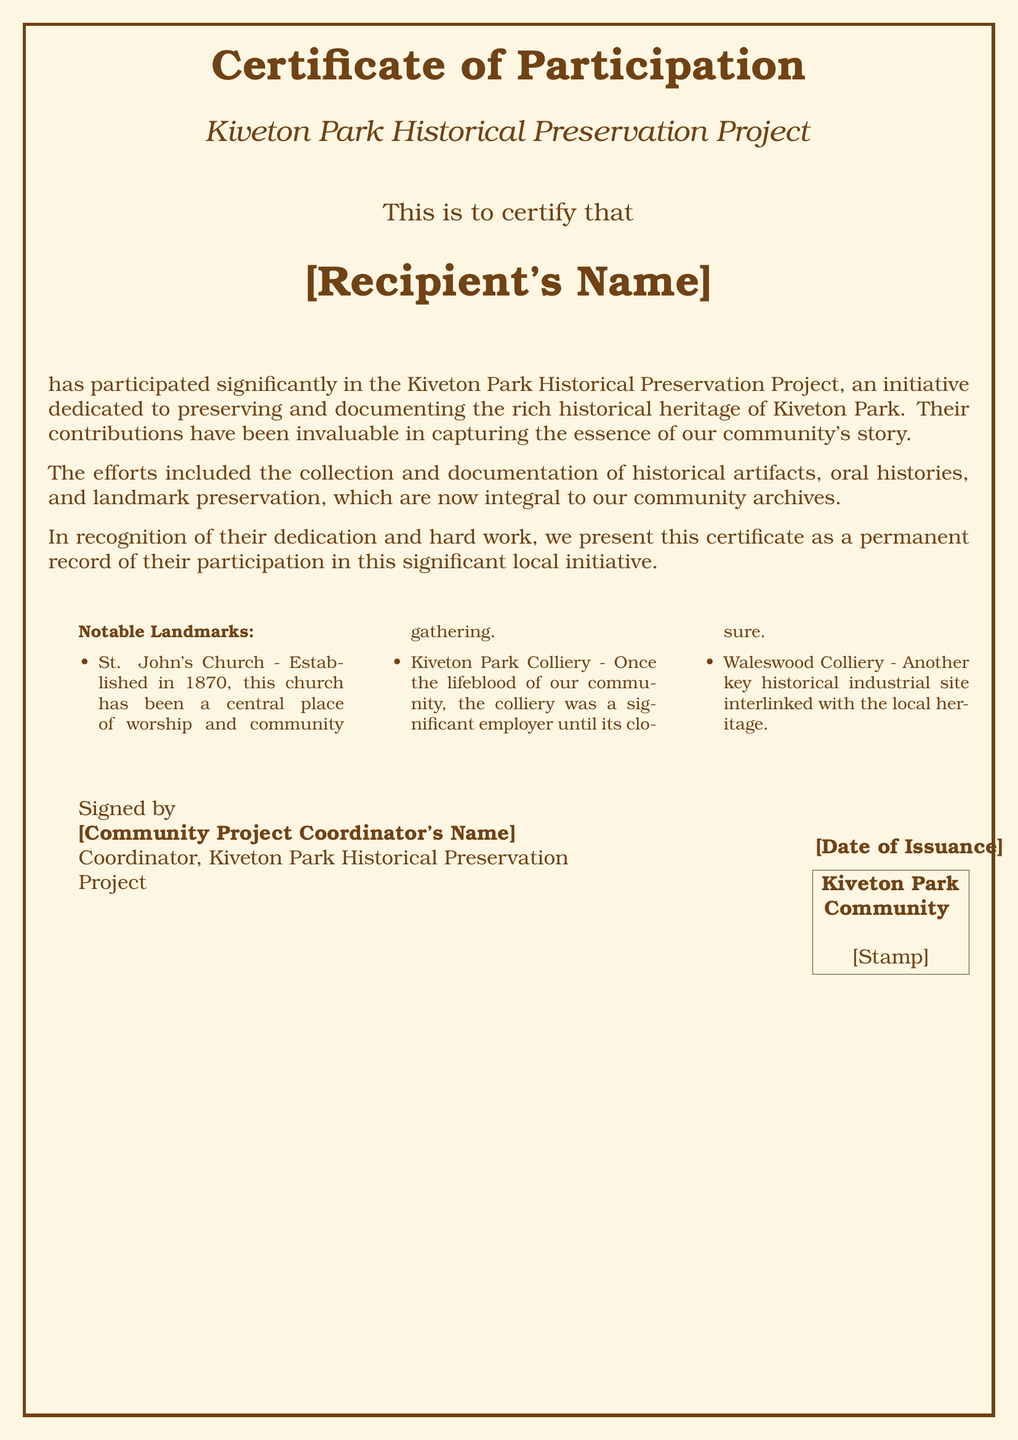What is the title of the certificate? The title is prominently displayed at the top of the document, summarizing its purpose.
Answer: Certificate of Participation What project is associated with this certificate? The project name is mentioned under the title and details the nature of the participation.
Answer: Kiveton Park Historical Preservation Project Who is the recipient of the certificate? The recipient's name is a placeholder indicating where the name will appear on the certificate.
Answer: [Recipient's Name] What does the certificate recognize? The document states its purpose in a specific sentence, highlighting what the participation entailed.
Answer: Participation significantly What date is associated with the issuance of the certificate? The date is specified in the section indicating when the certificate was issued.
Answer: [Date of Issuance] Who signed the certificate? The signature section includes a placeholder for the name of the individual responsible for signing.
Answer: [Community Project Coordinator's Name] What color is the background of the certificate? The document mentions the specific color used for the page background, enhancing its vintage look.
Answer: Old paper Name one of the notable landmarks mentioned. The document includes a list of landmarks that are integral to the historical project, which can be extracted.
Answer: St. John's Church What type of document is this? The structure and purpose of the document classify it uniquely within certain categories.
Answer: Certificate 